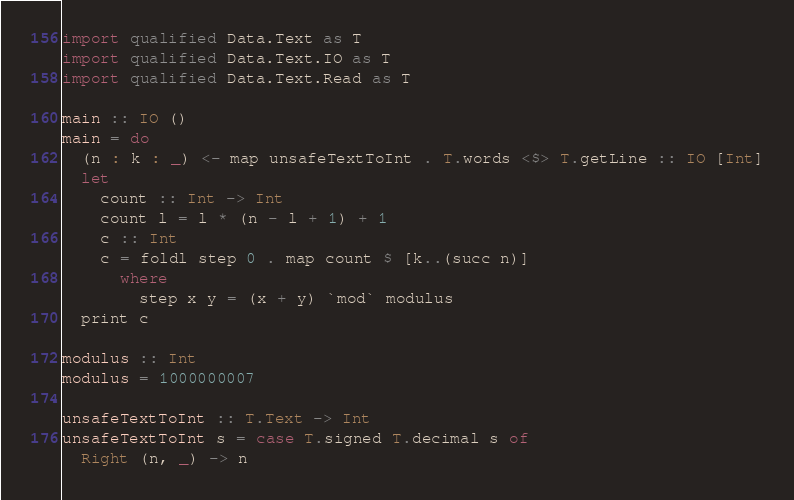<code> <loc_0><loc_0><loc_500><loc_500><_Haskell_>import qualified Data.Text as T
import qualified Data.Text.IO as T
import qualified Data.Text.Read as T

main :: IO ()
main = do
  (n : k : _) <- map unsafeTextToInt . T.words <$> T.getLine :: IO [Int]
  let
    count :: Int -> Int
    count l = l * (n - l + 1) + 1
    c :: Int
    c = foldl step 0 . map count $ [k..(succ n)]
      where
        step x y = (x + y) `mod` modulus
  print c

modulus :: Int
modulus = 1000000007

unsafeTextToInt :: T.Text -> Int
unsafeTextToInt s = case T.signed T.decimal s of
  Right (n, _) -> n
</code> 